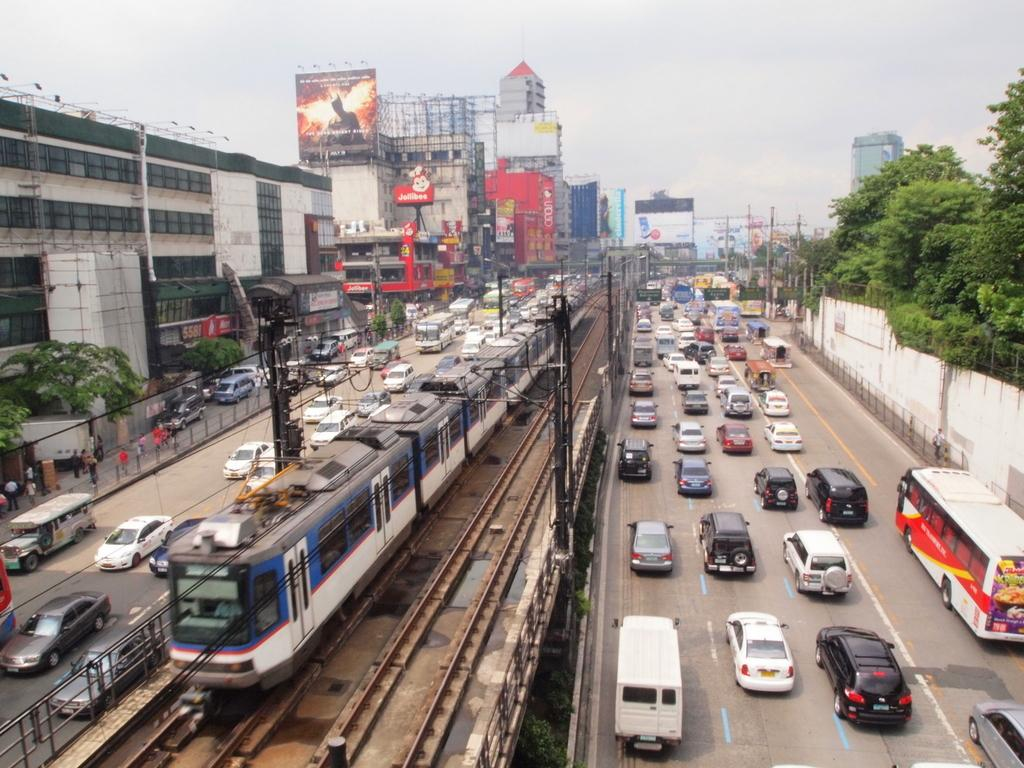What is the main subject in the middle of the image? There is a train in the middle of the image. What can be seen on the right side of the image? There are vehicles moving on the road on the right side of the image. What type of natural vegetation is present in the image? There are trees in the image. What type of structures are visible on the left side of the image? There are buildings on the left side of the image. What is visible at the top of the image? The sky is visible at the top of the image. Who is the creator of the volleyball in the image? There is no volleyball present in the image, so it is not possible to determine the creator. 